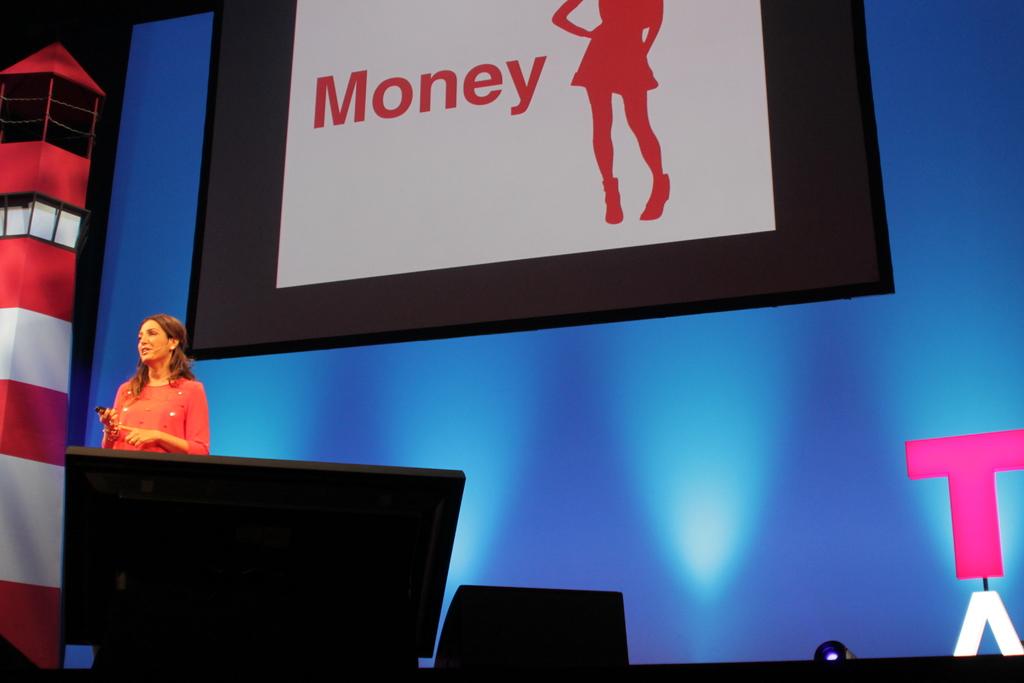What is the word written in red?
Your answer should be compact. Money. 